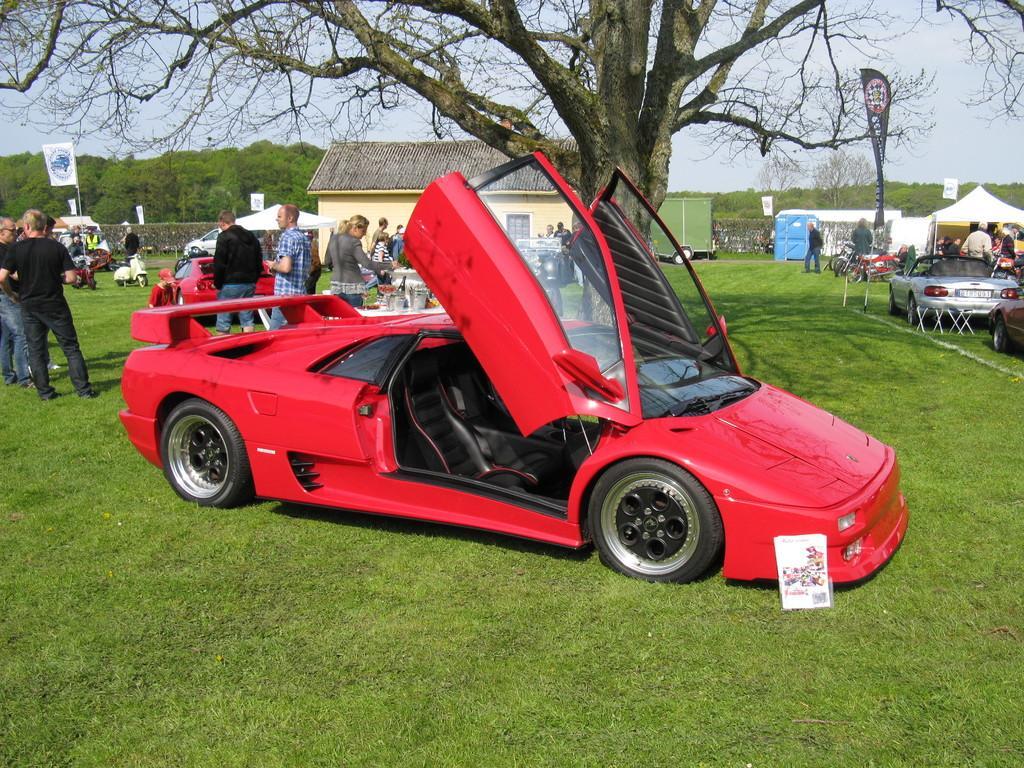Could you give a brief overview of what you see in this image? In this picture I can see a house and few tents and few flags and I can see cars parked and few people are standing and I can see scooters parked and I can see trees and grass on the ground and a cloudy sky. 